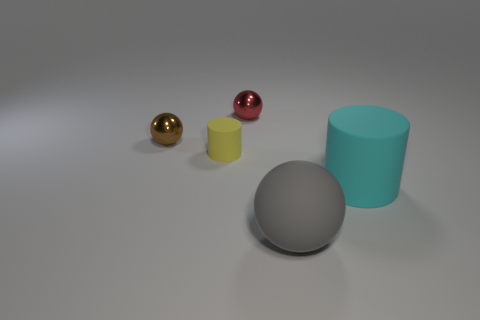Subtract all large rubber spheres. How many spheres are left? 2 Add 4 red spheres. How many objects exist? 9 Subtract 1 cylinders. How many cylinders are left? 1 Subtract all cylinders. How many objects are left? 3 Subtract all yellow cylinders. How many cylinders are left? 1 Subtract all purple cylinders. Subtract all blue balls. How many cylinders are left? 2 Subtract all tiny yellow cubes. Subtract all big cylinders. How many objects are left? 4 Add 4 gray rubber balls. How many gray rubber balls are left? 5 Add 1 yellow cylinders. How many yellow cylinders exist? 2 Subtract 1 red spheres. How many objects are left? 4 